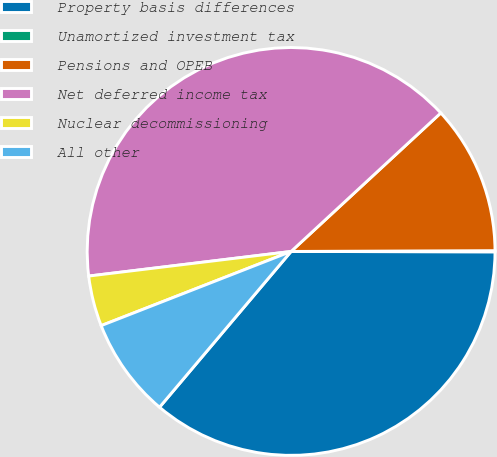Convert chart. <chart><loc_0><loc_0><loc_500><loc_500><pie_chart><fcel>Property basis differences<fcel>Unamortized investment tax<fcel>Pensions and OPEB<fcel>Net deferred income tax<fcel>Nuclear decommissioning<fcel>All other<nl><fcel>36.13%<fcel>0.09%<fcel>11.82%<fcel>40.04%<fcel>4.0%<fcel>7.91%<nl></chart> 